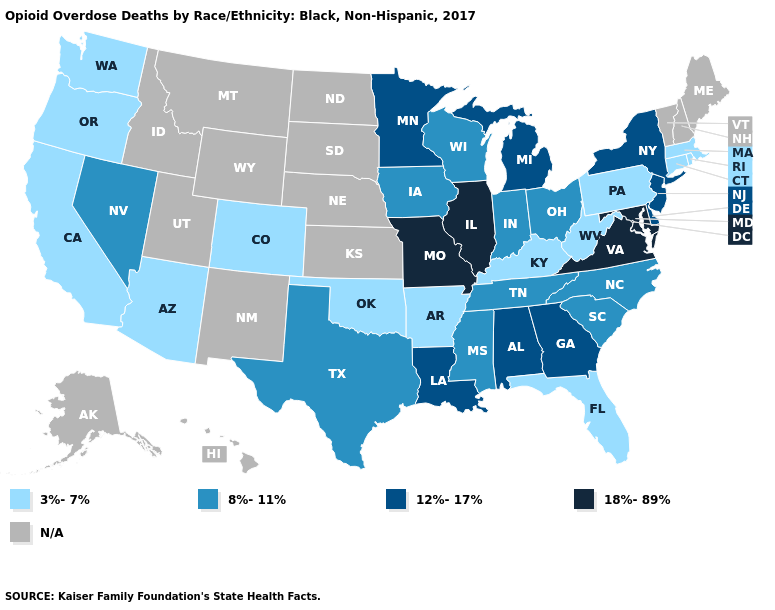Name the states that have a value in the range N/A?
Be succinct. Alaska, Hawaii, Idaho, Kansas, Maine, Montana, Nebraska, New Hampshire, New Mexico, North Dakota, South Dakota, Utah, Vermont, Wyoming. What is the value of Maine?
Quick response, please. N/A. Which states have the lowest value in the South?
Concise answer only. Arkansas, Florida, Kentucky, Oklahoma, West Virginia. What is the value of New York?
Be succinct. 12%-17%. What is the value of Utah?
Concise answer only. N/A. What is the value of Connecticut?
Short answer required. 3%-7%. Among the states that border Indiana , which have the highest value?
Write a very short answer. Illinois. Name the states that have a value in the range N/A?
Short answer required. Alaska, Hawaii, Idaho, Kansas, Maine, Montana, Nebraska, New Hampshire, New Mexico, North Dakota, South Dakota, Utah, Vermont, Wyoming. What is the highest value in the USA?
Concise answer only. 18%-89%. Name the states that have a value in the range 12%-17%?
Answer briefly. Alabama, Delaware, Georgia, Louisiana, Michigan, Minnesota, New Jersey, New York. What is the highest value in states that border North Carolina?
Concise answer only. 18%-89%. What is the value of Colorado?
Keep it brief. 3%-7%. 